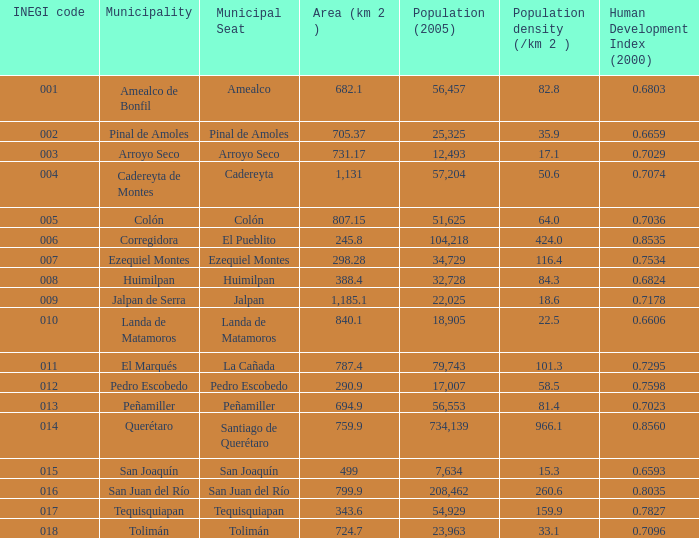For a region with a population of 54,929 (2005) and an area exceeding 343.6 km², what is its human development index (2000)? 0.0. 